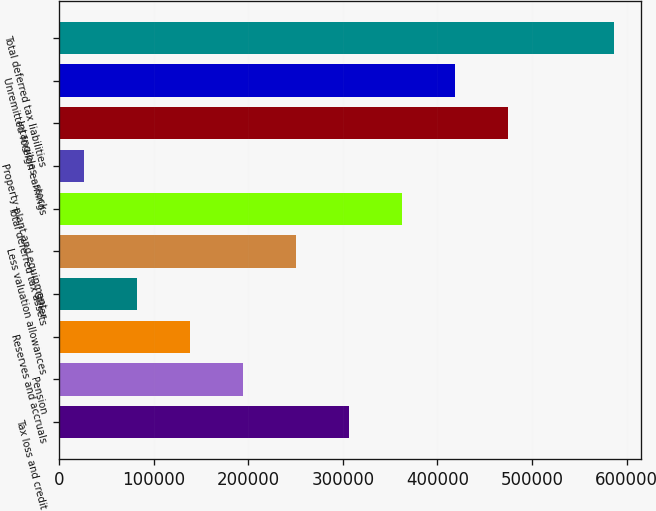<chart> <loc_0><loc_0><loc_500><loc_500><bar_chart><fcel>Tax loss and credit<fcel>Pension<fcel>Reserves and accruals<fcel>Other<fcel>Less valuation allowances<fcel>Total deferred tax assets<fcel>Property plant and equipment<fcel>Intangibles - stock<fcel>Unremitted foreign earnings<fcel>Total deferred tax liabilities<nl><fcel>306376<fcel>194446<fcel>138481<fcel>82515.3<fcel>250411<fcel>362342<fcel>26550<fcel>474272<fcel>418307<fcel>586203<nl></chart> 